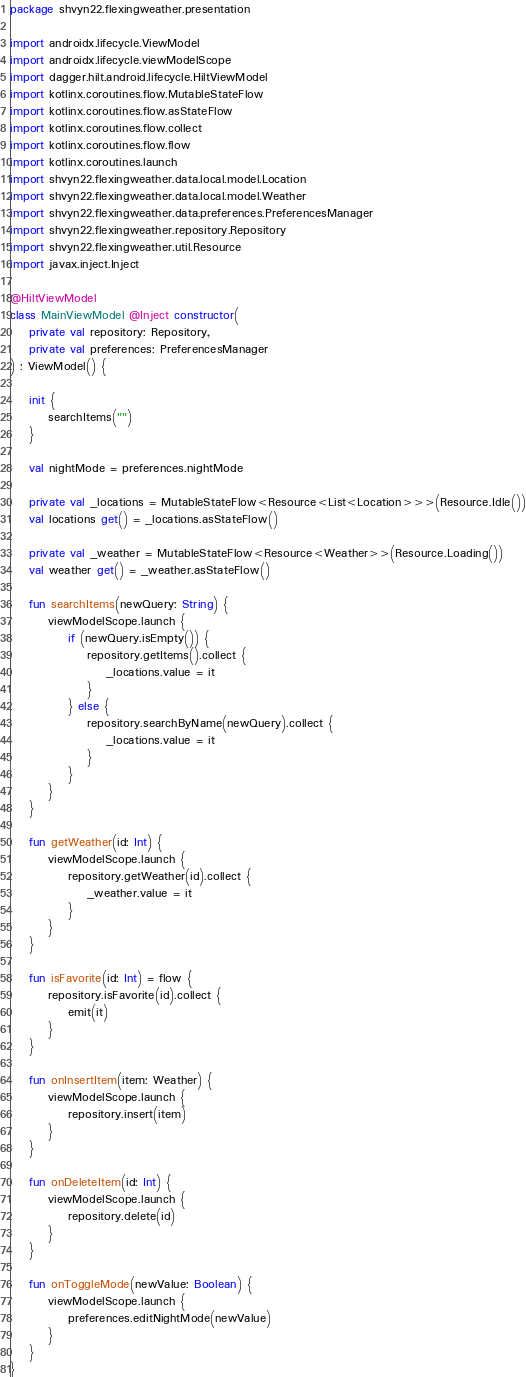Convert code to text. <code><loc_0><loc_0><loc_500><loc_500><_Kotlin_>package shvyn22.flexingweather.presentation

import androidx.lifecycle.ViewModel
import androidx.lifecycle.viewModelScope
import dagger.hilt.android.lifecycle.HiltViewModel
import kotlinx.coroutines.flow.MutableStateFlow
import kotlinx.coroutines.flow.asStateFlow
import kotlinx.coroutines.flow.collect
import kotlinx.coroutines.flow.flow
import kotlinx.coroutines.launch
import shvyn22.flexingweather.data.local.model.Location
import shvyn22.flexingweather.data.local.model.Weather
import shvyn22.flexingweather.data.preferences.PreferencesManager
import shvyn22.flexingweather.repository.Repository
import shvyn22.flexingweather.util.Resource
import javax.inject.Inject

@HiltViewModel
class MainViewModel @Inject constructor(
    private val repository: Repository,
    private val preferences: PreferencesManager
) : ViewModel() {

    init {
        searchItems("")
    }

    val nightMode = preferences.nightMode

    private val _locations = MutableStateFlow<Resource<List<Location>>>(Resource.Idle())
    val locations get() = _locations.asStateFlow()

    private val _weather = MutableStateFlow<Resource<Weather>>(Resource.Loading())
    val weather get() = _weather.asStateFlow()

    fun searchItems(newQuery: String) {
        viewModelScope.launch {
            if (newQuery.isEmpty()) {
                repository.getItems().collect {
                    _locations.value = it
                }
            } else {
                repository.searchByName(newQuery).collect {
                    _locations.value = it
                }
            }
        }
    }

    fun getWeather(id: Int) {
        viewModelScope.launch {
            repository.getWeather(id).collect {
                _weather.value = it
            }
        }
    }

    fun isFavorite(id: Int) = flow {
        repository.isFavorite(id).collect {
            emit(it)
        }
    }

    fun onInsertItem(item: Weather) {
        viewModelScope.launch {
            repository.insert(item)
        }
    }

    fun onDeleteItem(id: Int) {
        viewModelScope.launch {
            repository.delete(id)
        }
    }

    fun onToggleMode(newValue: Boolean) {
        viewModelScope.launch {
            preferences.editNightMode(newValue)
        }
    }
}</code> 